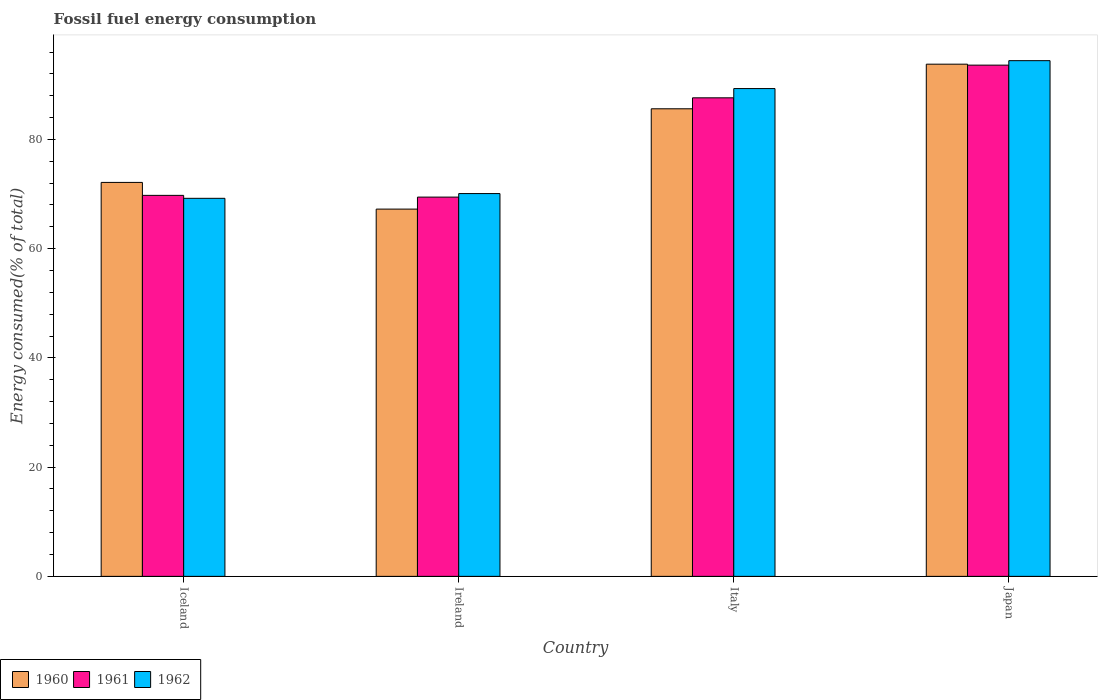How many different coloured bars are there?
Provide a short and direct response. 3. Are the number of bars per tick equal to the number of legend labels?
Provide a short and direct response. Yes. How many bars are there on the 1st tick from the left?
Provide a succinct answer. 3. In how many cases, is the number of bars for a given country not equal to the number of legend labels?
Make the answer very short. 0. What is the percentage of energy consumed in 1962 in Ireland?
Ensure brevity in your answer.  70.09. Across all countries, what is the maximum percentage of energy consumed in 1962?
Your answer should be very brief. 94.42. Across all countries, what is the minimum percentage of energy consumed in 1961?
Your answer should be compact. 69.44. In which country was the percentage of energy consumed in 1960 minimum?
Ensure brevity in your answer.  Ireland. What is the total percentage of energy consumed in 1960 in the graph?
Offer a very short reply. 318.76. What is the difference between the percentage of energy consumed in 1961 in Italy and that in Japan?
Give a very brief answer. -5.99. What is the difference between the percentage of energy consumed in 1960 in Ireland and the percentage of energy consumed in 1961 in Japan?
Provide a succinct answer. -26.36. What is the average percentage of energy consumed in 1961 per country?
Ensure brevity in your answer.  80.1. What is the difference between the percentage of energy consumed of/in 1960 and percentage of energy consumed of/in 1962 in Japan?
Make the answer very short. -0.64. What is the ratio of the percentage of energy consumed in 1962 in Iceland to that in Ireland?
Provide a succinct answer. 0.99. Is the difference between the percentage of energy consumed in 1960 in Ireland and Italy greater than the difference between the percentage of energy consumed in 1962 in Ireland and Italy?
Make the answer very short. Yes. What is the difference between the highest and the second highest percentage of energy consumed in 1960?
Give a very brief answer. -13.48. What is the difference between the highest and the lowest percentage of energy consumed in 1960?
Your answer should be compact. 26.53. In how many countries, is the percentage of energy consumed in 1961 greater than the average percentage of energy consumed in 1961 taken over all countries?
Offer a very short reply. 2. What does the 1st bar from the right in Italy represents?
Your response must be concise. 1962. How many bars are there?
Offer a very short reply. 12. Are all the bars in the graph horizontal?
Offer a very short reply. No. How many countries are there in the graph?
Ensure brevity in your answer.  4. What is the difference between two consecutive major ticks on the Y-axis?
Make the answer very short. 20. Are the values on the major ticks of Y-axis written in scientific E-notation?
Offer a very short reply. No. Does the graph contain any zero values?
Keep it short and to the point. No. Does the graph contain grids?
Ensure brevity in your answer.  No. How are the legend labels stacked?
Provide a short and direct response. Horizontal. What is the title of the graph?
Provide a succinct answer. Fossil fuel energy consumption. Does "1971" appear as one of the legend labels in the graph?
Keep it short and to the point. No. What is the label or title of the X-axis?
Ensure brevity in your answer.  Country. What is the label or title of the Y-axis?
Provide a succinct answer. Energy consumed(% of total). What is the Energy consumed(% of total) of 1960 in Iceland?
Provide a succinct answer. 72.13. What is the Energy consumed(% of total) of 1961 in Iceland?
Make the answer very short. 69.76. What is the Energy consumed(% of total) of 1962 in Iceland?
Ensure brevity in your answer.  69.22. What is the Energy consumed(% of total) of 1960 in Ireland?
Give a very brief answer. 67.24. What is the Energy consumed(% of total) in 1961 in Ireland?
Make the answer very short. 69.44. What is the Energy consumed(% of total) of 1962 in Ireland?
Ensure brevity in your answer.  70.09. What is the Energy consumed(% of total) of 1960 in Italy?
Ensure brevity in your answer.  85.61. What is the Energy consumed(% of total) in 1961 in Italy?
Make the answer very short. 87.62. What is the Energy consumed(% of total) of 1962 in Italy?
Ensure brevity in your answer.  89.31. What is the Energy consumed(% of total) in 1960 in Japan?
Provide a short and direct response. 93.78. What is the Energy consumed(% of total) in 1961 in Japan?
Offer a very short reply. 93.6. What is the Energy consumed(% of total) in 1962 in Japan?
Provide a short and direct response. 94.42. Across all countries, what is the maximum Energy consumed(% of total) in 1960?
Provide a short and direct response. 93.78. Across all countries, what is the maximum Energy consumed(% of total) in 1961?
Make the answer very short. 93.6. Across all countries, what is the maximum Energy consumed(% of total) of 1962?
Keep it short and to the point. 94.42. Across all countries, what is the minimum Energy consumed(% of total) of 1960?
Make the answer very short. 67.24. Across all countries, what is the minimum Energy consumed(% of total) of 1961?
Ensure brevity in your answer.  69.44. Across all countries, what is the minimum Energy consumed(% of total) of 1962?
Your answer should be compact. 69.22. What is the total Energy consumed(% of total) in 1960 in the graph?
Give a very brief answer. 318.76. What is the total Energy consumed(% of total) in 1961 in the graph?
Keep it short and to the point. 320.42. What is the total Energy consumed(% of total) of 1962 in the graph?
Make the answer very short. 323.04. What is the difference between the Energy consumed(% of total) in 1960 in Iceland and that in Ireland?
Ensure brevity in your answer.  4.89. What is the difference between the Energy consumed(% of total) of 1961 in Iceland and that in Ireland?
Your answer should be very brief. 0.32. What is the difference between the Energy consumed(% of total) in 1962 in Iceland and that in Ireland?
Keep it short and to the point. -0.87. What is the difference between the Energy consumed(% of total) of 1960 in Iceland and that in Italy?
Offer a very short reply. -13.48. What is the difference between the Energy consumed(% of total) of 1961 in Iceland and that in Italy?
Provide a succinct answer. -17.86. What is the difference between the Energy consumed(% of total) of 1962 in Iceland and that in Italy?
Provide a short and direct response. -20.09. What is the difference between the Energy consumed(% of total) in 1960 in Iceland and that in Japan?
Your response must be concise. -21.65. What is the difference between the Energy consumed(% of total) of 1961 in Iceland and that in Japan?
Ensure brevity in your answer.  -23.85. What is the difference between the Energy consumed(% of total) of 1962 in Iceland and that in Japan?
Provide a succinct answer. -25.2. What is the difference between the Energy consumed(% of total) of 1960 in Ireland and that in Italy?
Offer a terse response. -18.37. What is the difference between the Energy consumed(% of total) of 1961 in Ireland and that in Italy?
Your answer should be very brief. -18.18. What is the difference between the Energy consumed(% of total) in 1962 in Ireland and that in Italy?
Provide a short and direct response. -19.23. What is the difference between the Energy consumed(% of total) in 1960 in Ireland and that in Japan?
Provide a succinct answer. -26.53. What is the difference between the Energy consumed(% of total) of 1961 in Ireland and that in Japan?
Offer a terse response. -24.16. What is the difference between the Energy consumed(% of total) in 1962 in Ireland and that in Japan?
Your response must be concise. -24.34. What is the difference between the Energy consumed(% of total) in 1960 in Italy and that in Japan?
Ensure brevity in your answer.  -8.17. What is the difference between the Energy consumed(% of total) in 1961 in Italy and that in Japan?
Offer a very short reply. -5.99. What is the difference between the Energy consumed(% of total) of 1962 in Italy and that in Japan?
Offer a very short reply. -5.11. What is the difference between the Energy consumed(% of total) of 1960 in Iceland and the Energy consumed(% of total) of 1961 in Ireland?
Your answer should be very brief. 2.69. What is the difference between the Energy consumed(% of total) in 1960 in Iceland and the Energy consumed(% of total) in 1962 in Ireland?
Provide a short and direct response. 2.04. What is the difference between the Energy consumed(% of total) of 1961 in Iceland and the Energy consumed(% of total) of 1962 in Ireland?
Your answer should be very brief. -0.33. What is the difference between the Energy consumed(% of total) of 1960 in Iceland and the Energy consumed(% of total) of 1961 in Italy?
Your response must be concise. -15.49. What is the difference between the Energy consumed(% of total) of 1960 in Iceland and the Energy consumed(% of total) of 1962 in Italy?
Your answer should be very brief. -17.18. What is the difference between the Energy consumed(% of total) of 1961 in Iceland and the Energy consumed(% of total) of 1962 in Italy?
Provide a short and direct response. -19.55. What is the difference between the Energy consumed(% of total) of 1960 in Iceland and the Energy consumed(% of total) of 1961 in Japan?
Provide a short and direct response. -21.48. What is the difference between the Energy consumed(% of total) of 1960 in Iceland and the Energy consumed(% of total) of 1962 in Japan?
Your response must be concise. -22.29. What is the difference between the Energy consumed(% of total) in 1961 in Iceland and the Energy consumed(% of total) in 1962 in Japan?
Offer a terse response. -24.66. What is the difference between the Energy consumed(% of total) of 1960 in Ireland and the Energy consumed(% of total) of 1961 in Italy?
Provide a short and direct response. -20.38. What is the difference between the Energy consumed(% of total) of 1960 in Ireland and the Energy consumed(% of total) of 1962 in Italy?
Your answer should be very brief. -22.07. What is the difference between the Energy consumed(% of total) in 1961 in Ireland and the Energy consumed(% of total) in 1962 in Italy?
Your response must be concise. -19.87. What is the difference between the Energy consumed(% of total) of 1960 in Ireland and the Energy consumed(% of total) of 1961 in Japan?
Provide a succinct answer. -26.36. What is the difference between the Energy consumed(% of total) of 1960 in Ireland and the Energy consumed(% of total) of 1962 in Japan?
Provide a short and direct response. -27.18. What is the difference between the Energy consumed(% of total) of 1961 in Ireland and the Energy consumed(% of total) of 1962 in Japan?
Make the answer very short. -24.98. What is the difference between the Energy consumed(% of total) in 1960 in Italy and the Energy consumed(% of total) in 1961 in Japan?
Offer a very short reply. -7.99. What is the difference between the Energy consumed(% of total) of 1960 in Italy and the Energy consumed(% of total) of 1962 in Japan?
Your response must be concise. -8.81. What is the difference between the Energy consumed(% of total) in 1961 in Italy and the Energy consumed(% of total) in 1962 in Japan?
Give a very brief answer. -6.8. What is the average Energy consumed(% of total) in 1960 per country?
Keep it short and to the point. 79.69. What is the average Energy consumed(% of total) in 1961 per country?
Ensure brevity in your answer.  80.1. What is the average Energy consumed(% of total) of 1962 per country?
Ensure brevity in your answer.  80.76. What is the difference between the Energy consumed(% of total) of 1960 and Energy consumed(% of total) of 1961 in Iceland?
Provide a succinct answer. 2.37. What is the difference between the Energy consumed(% of total) of 1960 and Energy consumed(% of total) of 1962 in Iceland?
Give a very brief answer. 2.91. What is the difference between the Energy consumed(% of total) in 1961 and Energy consumed(% of total) in 1962 in Iceland?
Provide a succinct answer. 0.54. What is the difference between the Energy consumed(% of total) in 1960 and Energy consumed(% of total) in 1961 in Ireland?
Provide a short and direct response. -2.2. What is the difference between the Energy consumed(% of total) of 1960 and Energy consumed(% of total) of 1962 in Ireland?
Your answer should be compact. -2.84. What is the difference between the Energy consumed(% of total) in 1961 and Energy consumed(% of total) in 1962 in Ireland?
Make the answer very short. -0.65. What is the difference between the Energy consumed(% of total) in 1960 and Energy consumed(% of total) in 1961 in Italy?
Your response must be concise. -2.01. What is the difference between the Energy consumed(% of total) in 1960 and Energy consumed(% of total) in 1962 in Italy?
Provide a succinct answer. -3.7. What is the difference between the Energy consumed(% of total) of 1961 and Energy consumed(% of total) of 1962 in Italy?
Ensure brevity in your answer.  -1.69. What is the difference between the Energy consumed(% of total) in 1960 and Energy consumed(% of total) in 1961 in Japan?
Provide a short and direct response. 0.17. What is the difference between the Energy consumed(% of total) of 1960 and Energy consumed(% of total) of 1962 in Japan?
Ensure brevity in your answer.  -0.64. What is the difference between the Energy consumed(% of total) of 1961 and Energy consumed(% of total) of 1962 in Japan?
Offer a terse response. -0.82. What is the ratio of the Energy consumed(% of total) in 1960 in Iceland to that in Ireland?
Make the answer very short. 1.07. What is the ratio of the Energy consumed(% of total) in 1962 in Iceland to that in Ireland?
Offer a very short reply. 0.99. What is the ratio of the Energy consumed(% of total) of 1960 in Iceland to that in Italy?
Ensure brevity in your answer.  0.84. What is the ratio of the Energy consumed(% of total) of 1961 in Iceland to that in Italy?
Offer a terse response. 0.8. What is the ratio of the Energy consumed(% of total) of 1962 in Iceland to that in Italy?
Your response must be concise. 0.78. What is the ratio of the Energy consumed(% of total) of 1960 in Iceland to that in Japan?
Keep it short and to the point. 0.77. What is the ratio of the Energy consumed(% of total) of 1961 in Iceland to that in Japan?
Offer a very short reply. 0.75. What is the ratio of the Energy consumed(% of total) of 1962 in Iceland to that in Japan?
Give a very brief answer. 0.73. What is the ratio of the Energy consumed(% of total) in 1960 in Ireland to that in Italy?
Your answer should be compact. 0.79. What is the ratio of the Energy consumed(% of total) in 1961 in Ireland to that in Italy?
Your answer should be very brief. 0.79. What is the ratio of the Energy consumed(% of total) of 1962 in Ireland to that in Italy?
Your answer should be very brief. 0.78. What is the ratio of the Energy consumed(% of total) of 1960 in Ireland to that in Japan?
Ensure brevity in your answer.  0.72. What is the ratio of the Energy consumed(% of total) in 1961 in Ireland to that in Japan?
Your answer should be compact. 0.74. What is the ratio of the Energy consumed(% of total) of 1962 in Ireland to that in Japan?
Offer a very short reply. 0.74. What is the ratio of the Energy consumed(% of total) in 1960 in Italy to that in Japan?
Offer a terse response. 0.91. What is the ratio of the Energy consumed(% of total) of 1961 in Italy to that in Japan?
Offer a very short reply. 0.94. What is the ratio of the Energy consumed(% of total) in 1962 in Italy to that in Japan?
Give a very brief answer. 0.95. What is the difference between the highest and the second highest Energy consumed(% of total) of 1960?
Your answer should be compact. 8.17. What is the difference between the highest and the second highest Energy consumed(% of total) in 1961?
Ensure brevity in your answer.  5.99. What is the difference between the highest and the second highest Energy consumed(% of total) of 1962?
Provide a short and direct response. 5.11. What is the difference between the highest and the lowest Energy consumed(% of total) in 1960?
Your answer should be very brief. 26.53. What is the difference between the highest and the lowest Energy consumed(% of total) in 1961?
Your answer should be compact. 24.16. What is the difference between the highest and the lowest Energy consumed(% of total) in 1962?
Ensure brevity in your answer.  25.2. 